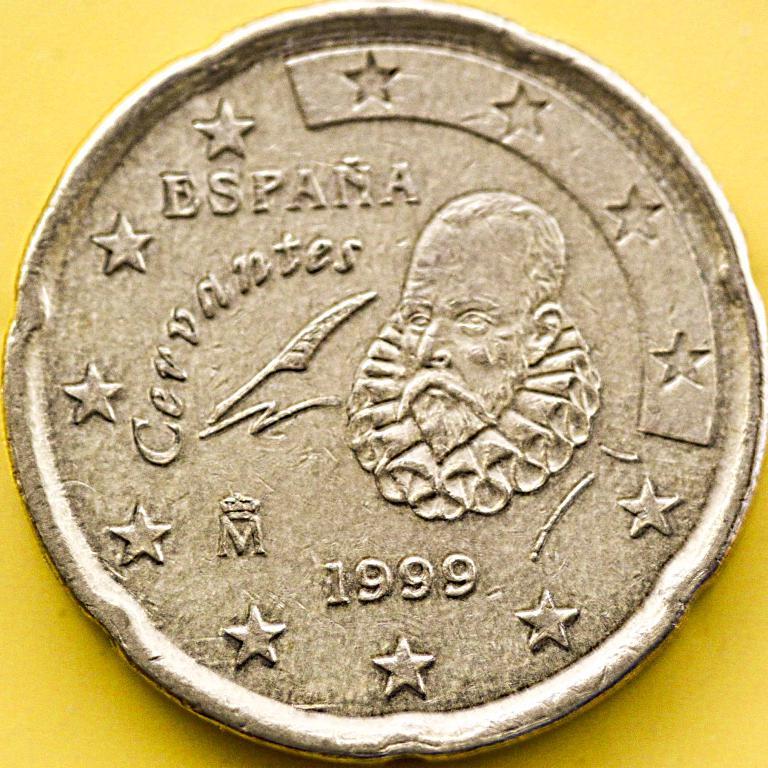When is this coin minted?
Provide a short and direct response. 1999. What country is mentioned?
Keep it short and to the point. Espana. 